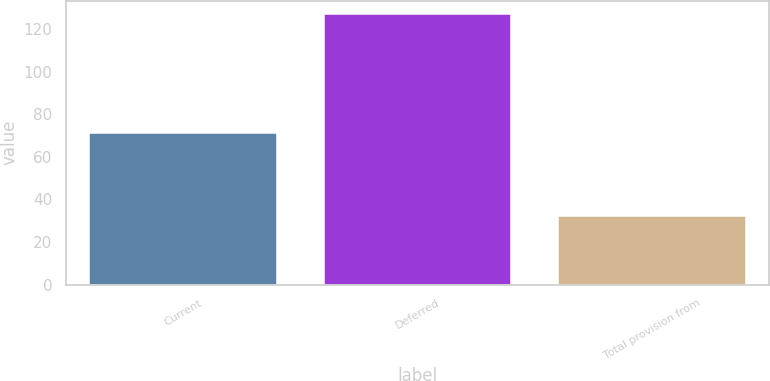Convert chart. <chart><loc_0><loc_0><loc_500><loc_500><bar_chart><fcel>Current<fcel>Deferred<fcel>Total provision from<nl><fcel>71<fcel>127<fcel>32<nl></chart> 